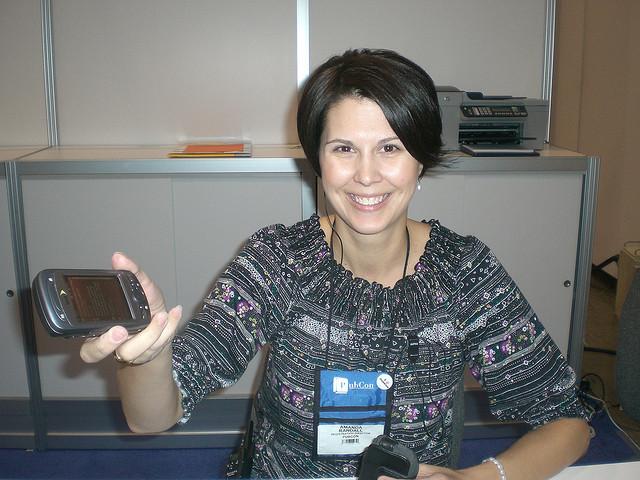What is the lady holding in her right hand?
Keep it brief. Phone. What is on the back counter?
Answer briefly. Printer. What color is the lady's top?
Keep it brief. Gray. 